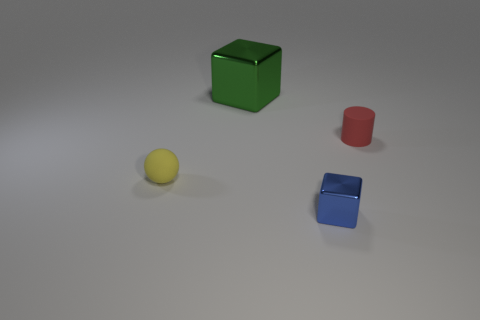Are there any other things that are the same size as the green metal block?
Your response must be concise. No. There is a tiny shiny object that is the same shape as the big metallic thing; what is its color?
Your response must be concise. Blue. Are there fewer big brown balls than tiny red rubber cylinders?
Make the answer very short. Yes. Do the yellow matte object and the block that is behind the tiny yellow rubber sphere have the same size?
Offer a very short reply. No. The matte thing that is to the left of the cube behind the yellow rubber sphere is what color?
Provide a succinct answer. Yellow. How many objects are metal blocks in front of the tiny red cylinder or small matte objects that are left of the big green block?
Keep it short and to the point. 2. Do the blue cube and the cylinder have the same size?
Make the answer very short. Yes. There is a small rubber thing that is to the left of the blue metallic object; is its shape the same as the matte thing that is to the right of the large thing?
Your answer should be very brief. No. The matte ball is what size?
Your answer should be very brief. Small. What material is the green thing behind the metal block on the right side of the block that is behind the cylinder?
Make the answer very short. Metal. 